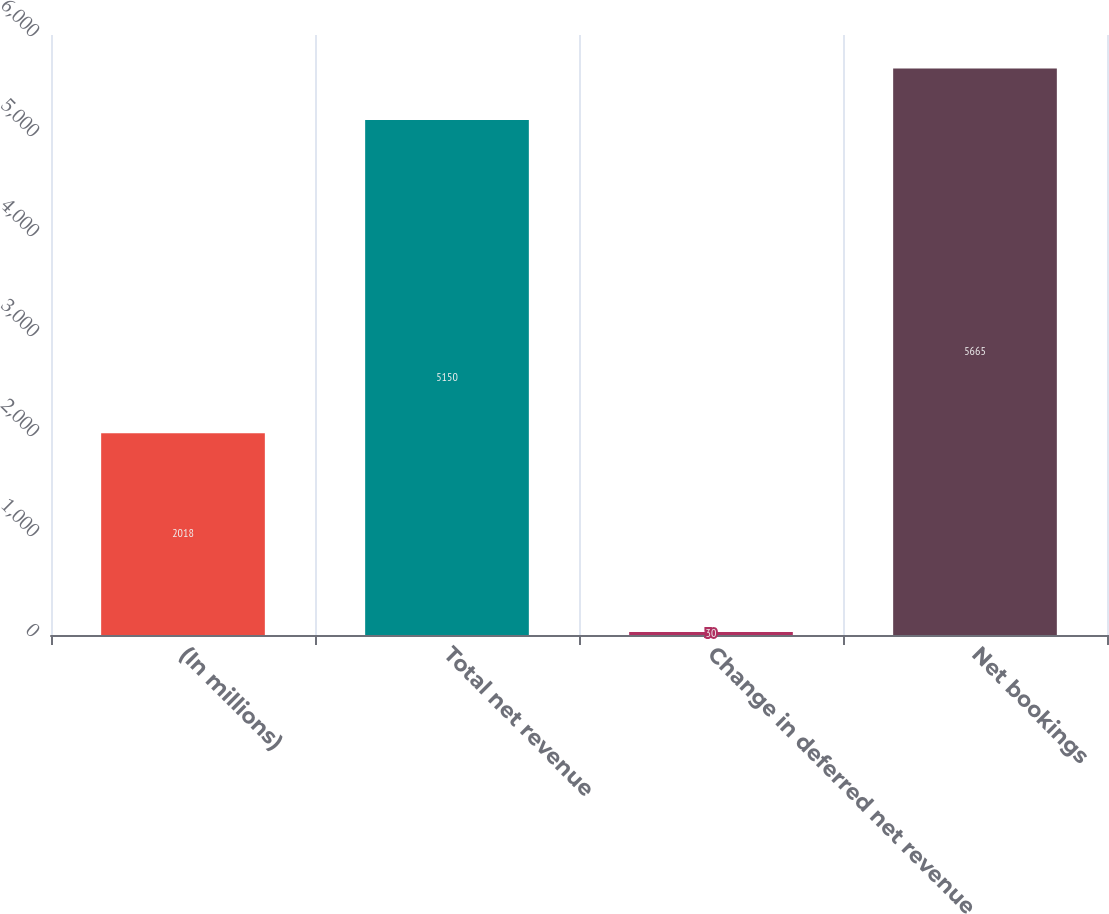<chart> <loc_0><loc_0><loc_500><loc_500><bar_chart><fcel>(In millions)<fcel>Total net revenue<fcel>Change in deferred net revenue<fcel>Net bookings<nl><fcel>2018<fcel>5150<fcel>30<fcel>5665<nl></chart> 